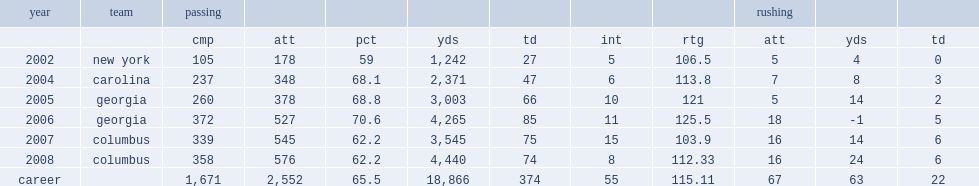How many passing yards did nagy get in 2002? 1242.0. 